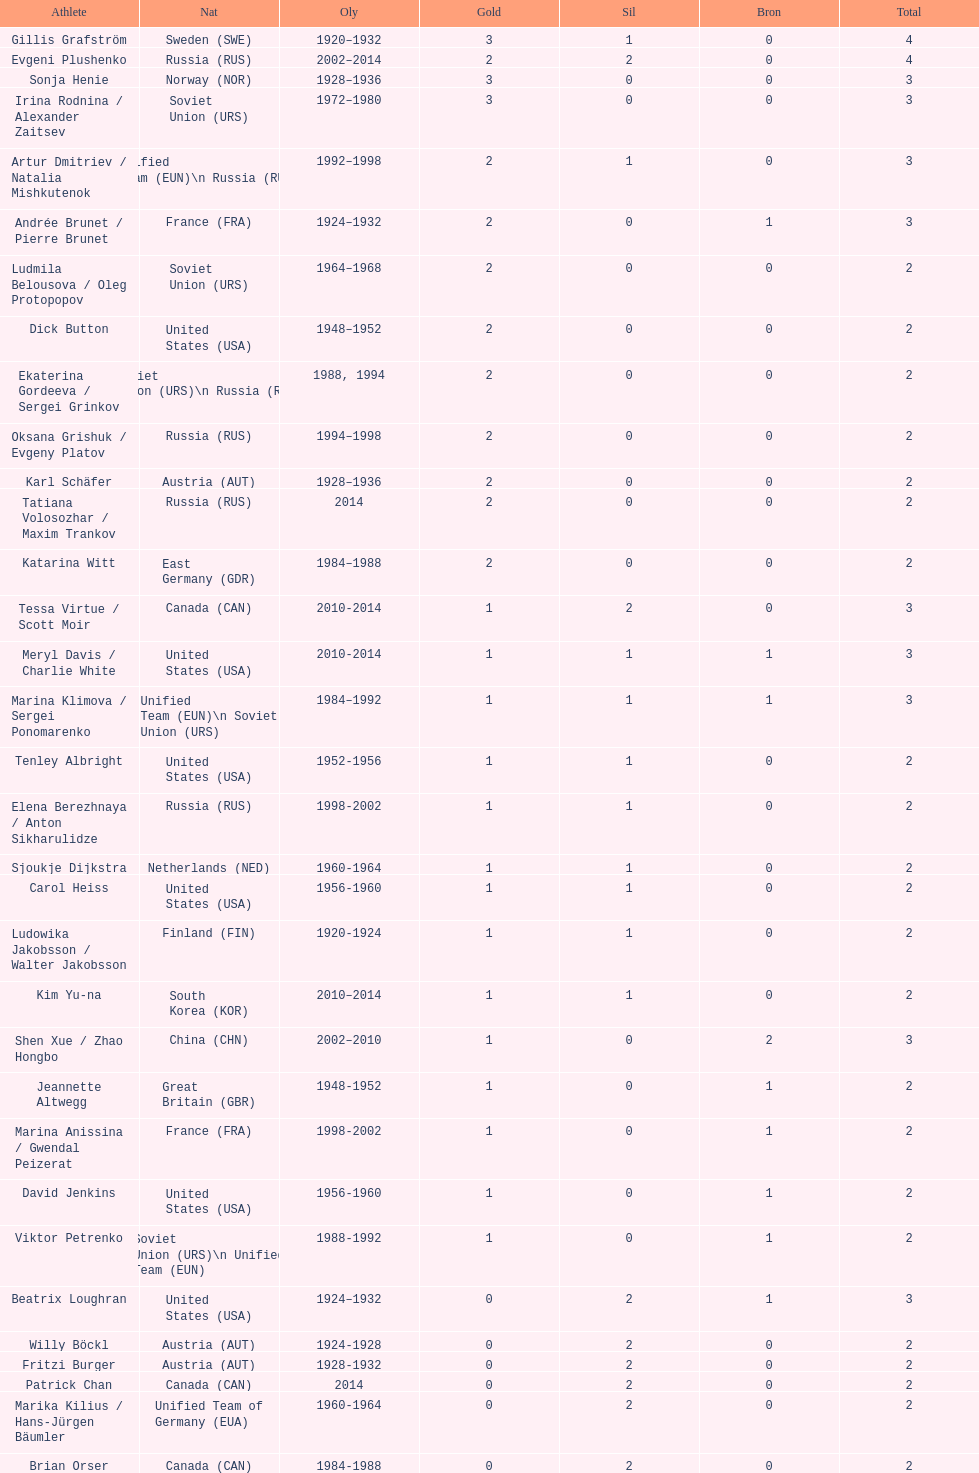What was the greatest number of gold medals won by a single athlete? 3. 